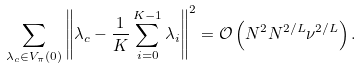Convert formula to latex. <formula><loc_0><loc_0><loc_500><loc_500>\sum _ { \lambda _ { c } \in V _ { \pi } ( 0 ) } \left \| \lambda _ { c } - \frac { 1 } K \sum _ { i = 0 } ^ { K - 1 } \lambda _ { i } \right \| ^ { 2 } = \mathcal { O } \left ( N ^ { 2 } N ^ { 2 / L } \nu ^ { 2 / L } \right ) .</formula> 